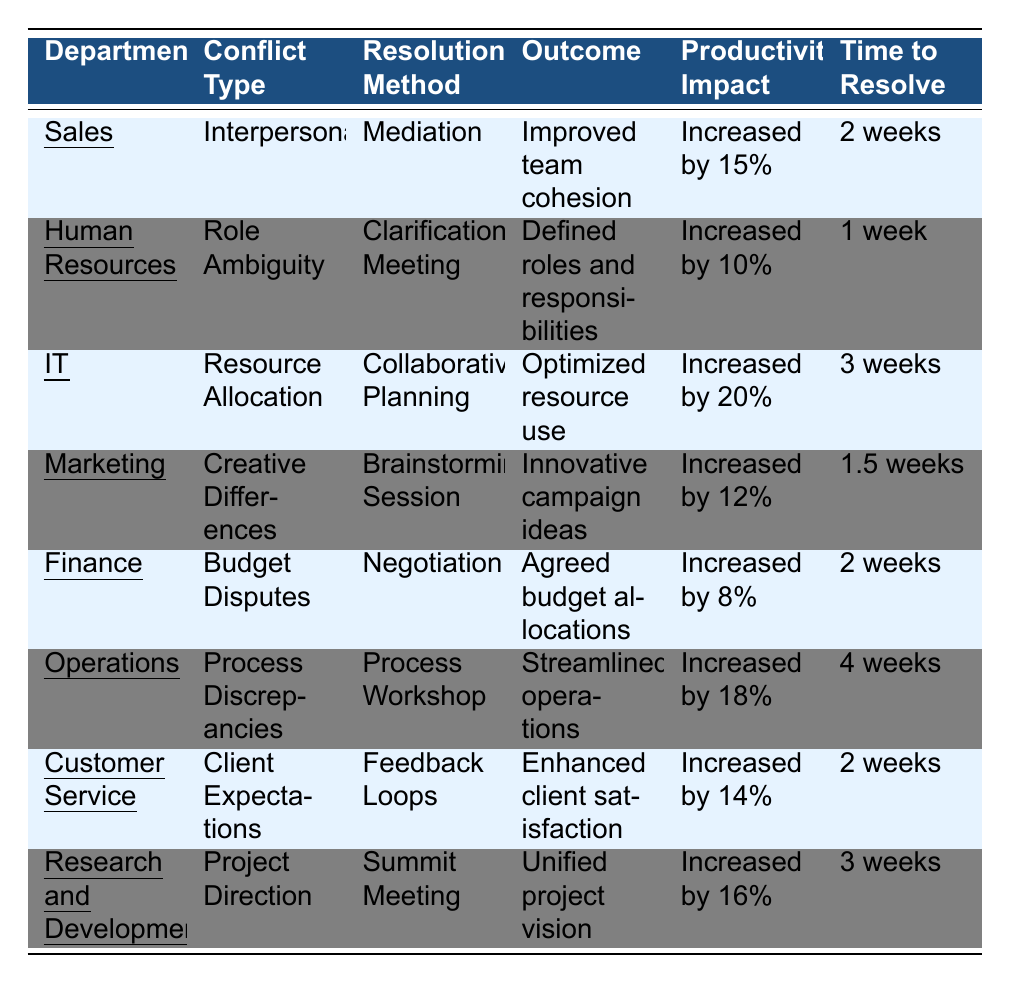What is the productivity impact of the IT department's conflict resolution? The IT department's conflict resolution achieved a productivity impact of "Increased by 20%."
Answer: Increased by 20% How long did it take to resolve the conflict in the Human Resources department? The conflict in the Human Resources department took "1 week" to resolve.
Answer: 1 week Which department had the highest productivity impact from conflict resolution? The IT department had the highest productivity impact, which was "Increased by 20%."
Answer: IT department What was the outcome of the conflict resolution in the Sales department? The outcome of the conflict resolution in the Sales department was "Improved team cohesion."
Answer: Improved team cohesion Did the Operations department have a resolution method that lasted more than three weeks? Yes, the Operations department used "Process Workshop," which took "4 weeks" to resolve.
Answer: Yes What is the average productivity increase across all departments? To find the average, add the productivity impacts: 15 + 10 + 20 + 12 + 8 + 18 + 14 + 16 = 123. There are 8 departments, so the average is 123 / 8 = 15.375%.
Answer: 15.375% Which departments resolved conflicts with a time frame of 2 weeks? The departments that resolved conflicts in 2 weeks are Sales, Finance, and Customer Service.
Answer: Sales, Finance, Customer Service What was the resolution method in the Marketing department? The resolution method used in the Marketing department was "Brainstorming Session."
Answer: Brainstorming Session How many departments had a productivity impact of less than 15%? The Finance department had a productivity impact of "Increased by 8%," which is less than 15%. Therefore, only one department meets this criterion.
Answer: 1 Combine all productivity increases from departments that resolved conflicts within 2 weeks. The departments that resolved conflicts in 2 weeks are Sales (15%), Finance (8%), and Customer Service (14%). Adding these yields 15 + 8 + 14 = 37%.
Answer: 37% 